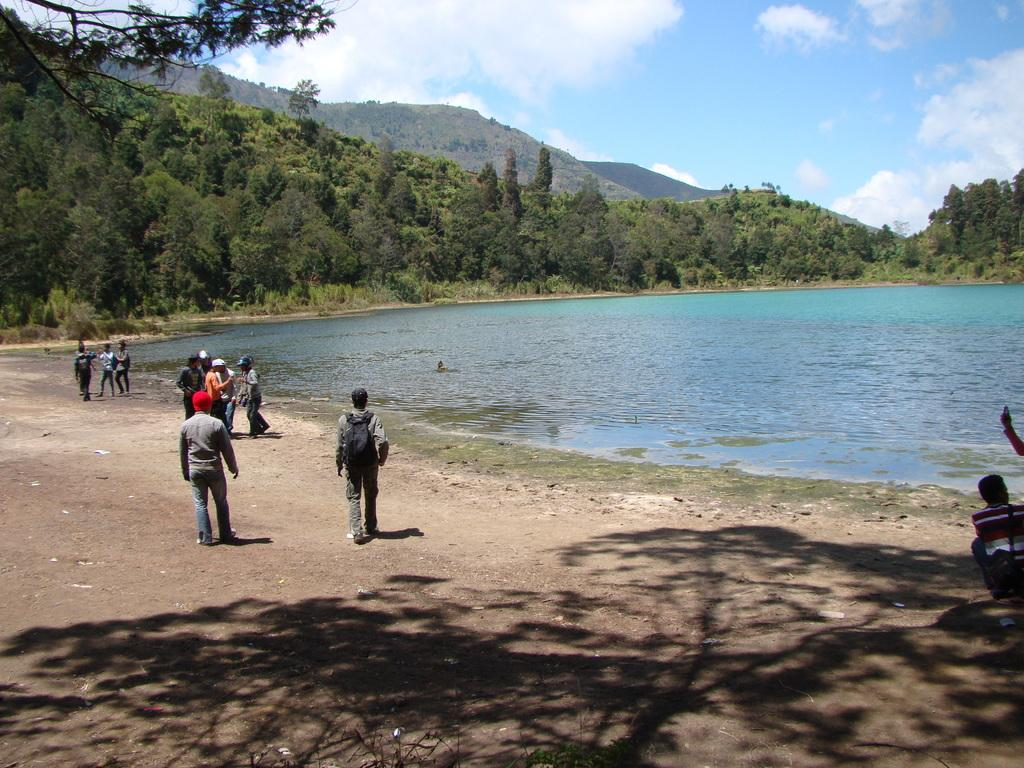What is the main setting of the image? There are people standing on a land in the image. What can be seen in the background of the image? There is a pond, trees, mountains, and the sky visible in the background of the image. What type of sweater is the porter wearing while selling tickets in the image? There is no porter or ticket-selling activity present in the image. 